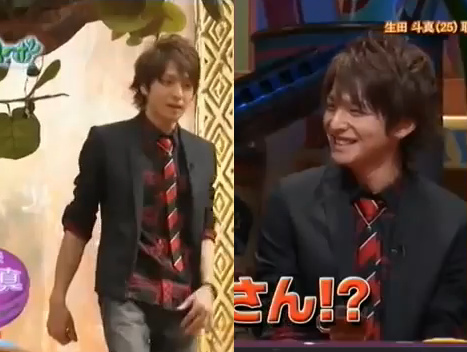Is there a chair in the picture? No, there is no chair in the picture. 